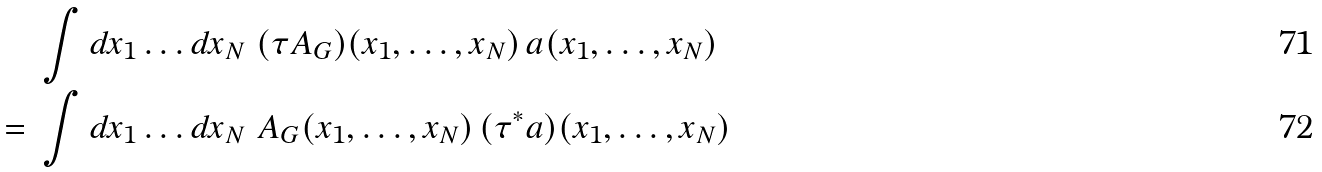<formula> <loc_0><loc_0><loc_500><loc_500>& \ \int d x _ { 1 } \dots d x _ { N } \ ( \tau A _ { G } ) ( x _ { 1 } , \dots , x _ { N } ) \, a ( x _ { 1 } , \dots , x _ { N } ) \\ = & \ \int d x _ { 1 } \dots d x _ { N } \ A _ { G } ( x _ { 1 } , \dots , x _ { N } ) \, ( \tau ^ { \ast } a ) ( x _ { 1 } , \dots , x _ { N } )</formula> 